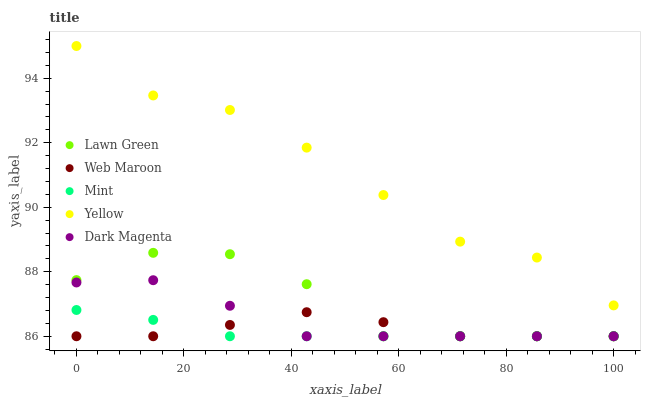Does Mint have the minimum area under the curve?
Answer yes or no. Yes. Does Yellow have the maximum area under the curve?
Answer yes or no. Yes. Does Web Maroon have the minimum area under the curve?
Answer yes or no. No. Does Web Maroon have the maximum area under the curve?
Answer yes or no. No. Is Mint the smoothest?
Answer yes or no. Yes. Is Lawn Green the roughest?
Answer yes or no. Yes. Is Web Maroon the smoothest?
Answer yes or no. No. Is Web Maroon the roughest?
Answer yes or no. No. Does Lawn Green have the lowest value?
Answer yes or no. Yes. Does Yellow have the lowest value?
Answer yes or no. No. Does Yellow have the highest value?
Answer yes or no. Yes. Does Mint have the highest value?
Answer yes or no. No. Is Lawn Green less than Yellow?
Answer yes or no. Yes. Is Yellow greater than Mint?
Answer yes or no. Yes. Does Web Maroon intersect Lawn Green?
Answer yes or no. Yes. Is Web Maroon less than Lawn Green?
Answer yes or no. No. Is Web Maroon greater than Lawn Green?
Answer yes or no. No. Does Lawn Green intersect Yellow?
Answer yes or no. No. 